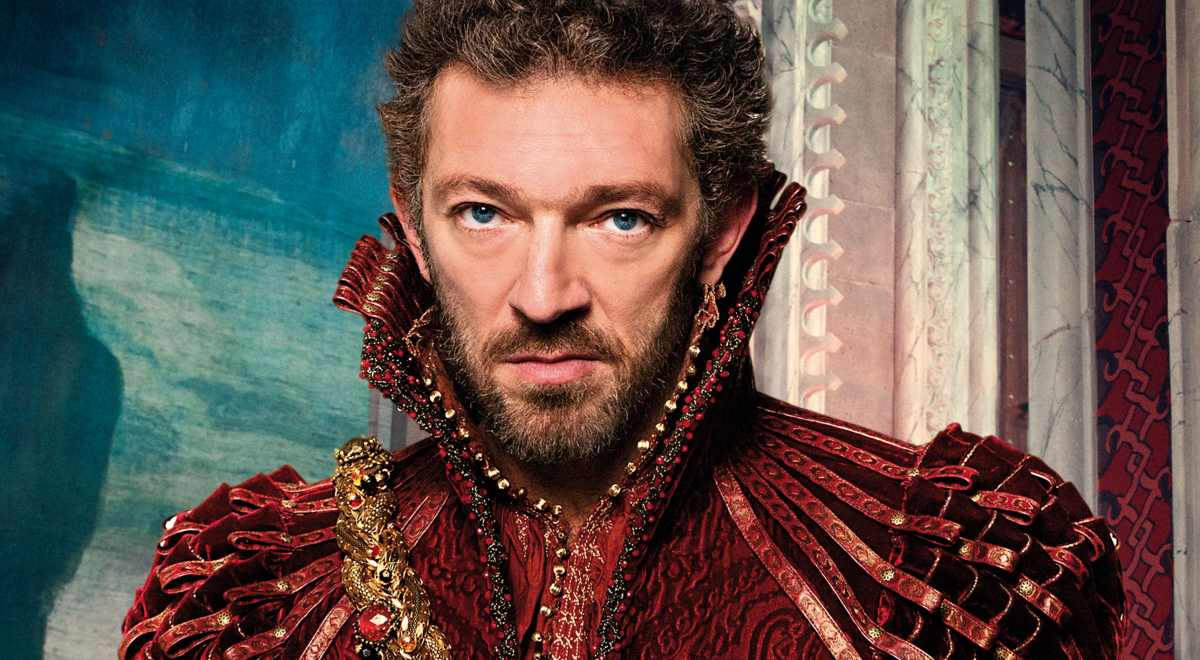Create a vivid story surrounding the character portrayed in the image. In a kingdom long forgotten by the sands of time, there lived a duke named Alaric, renowned for his wisdom and his impenetrable gaze. The red and gold attire was a symbol of his status and his unwavering courage in battle. Legends say that the gold in his collar came from the treasure of a dragon he once defeated. Standing by the grand window of his fortress, framed by the luxurious decor, he pondered the fate of his domain as political intrigues loomed on the horizon. His expression, fierce yet contemplative, signified the weight of the decisions he was to make for the safety and prosperity of his people. How did Alaric come to possess such an imposing and grand fortress? Alaric's fortress, renowned throughout the kingdom for its unparalleled grandeur, was not only a product of his own wealth but also of his strategic mind and leadership. Decades prior, the region was fragmented and plagued by incessant conflicts among rival clans. Young Alaric, then a rising leader with an unyielding spirit, unified these clans through a mix of tactical prowess, diplomacy, and pivotal alliances. To consolidate his rule and provide a haven for his new allies, he commissioned the construction of the fortress atop an ancient hillside, where legends spoke of forgotten magic and hidden strength beneath its stones. This stronghold became a symbol of his legacy and a towering beacon of unity and power in the realm. If Alaric were to host a grand ball in his fortress, what kind of ambiance and events might attendees expect? Alaric's grand ball would be the epitome of opulence and splendor. The grand hall, illuminated by chandeliers dripping with crystals, would be draped in rich fabrics of crimson and gold, echoing the duke's personal colors. Guests, donned in the finest silks and brocades, would be welcomed by an orchestra playing enchanting melodies. Lavish feasts featuring exotic dishes from distant lands would adorn long banquet tables. The evening would be filled with intricate dances, diplomatic exchanges, and whispered secrets, as the elite of the kingdom vied for the duke's favor and the alliances that came with it. Amidst the revelry, Alaric would observe, ever watchful, his piercing gaze ensuring that the night's events would fortify his position and the future of his realm. 